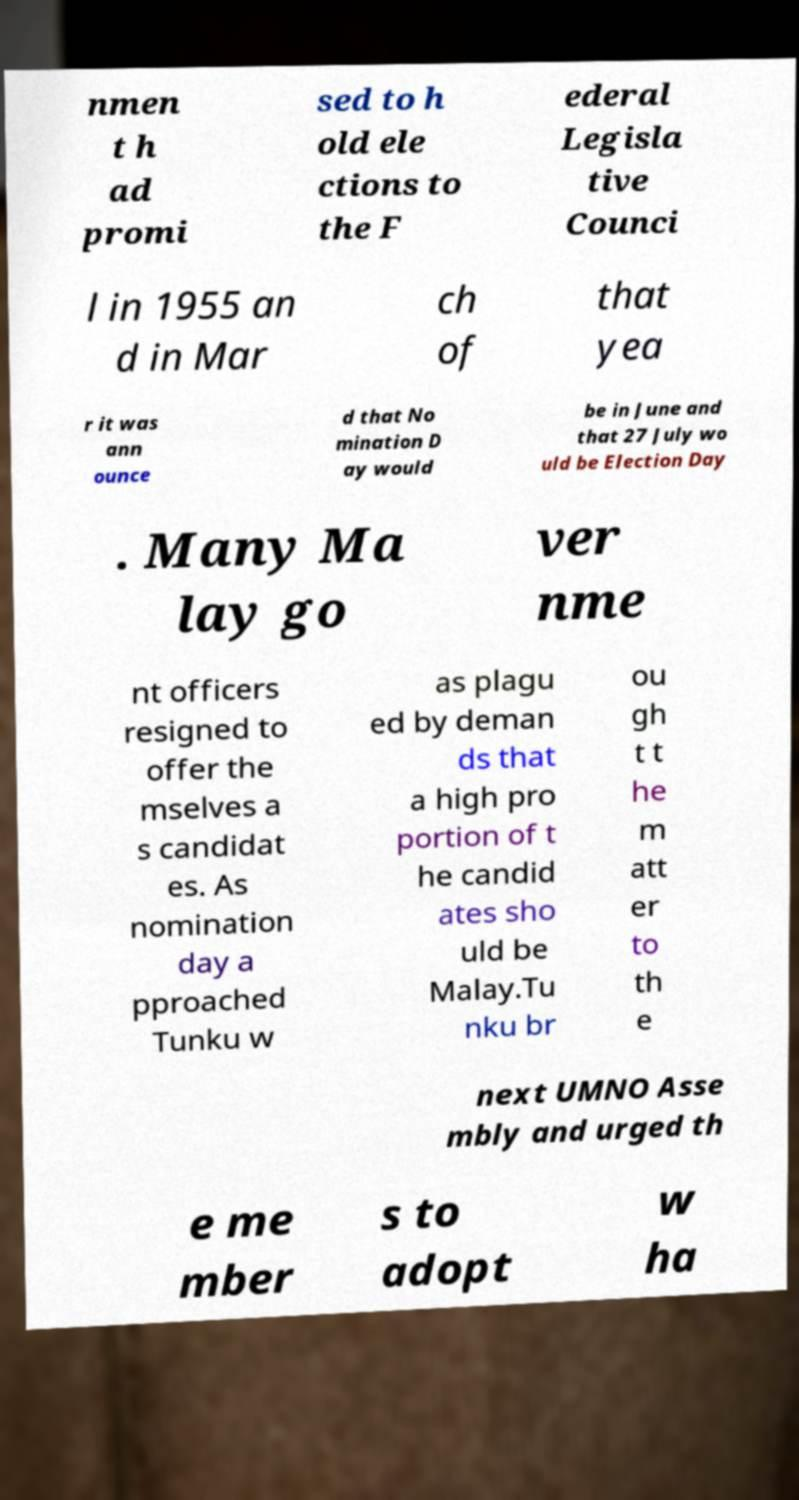Could you assist in decoding the text presented in this image and type it out clearly? nmen t h ad promi sed to h old ele ctions to the F ederal Legisla tive Counci l in 1955 an d in Mar ch of that yea r it was ann ounce d that No mination D ay would be in June and that 27 July wo uld be Election Day . Many Ma lay go ver nme nt officers resigned to offer the mselves a s candidat es. As nomination day a pproached Tunku w as plagu ed by deman ds that a high pro portion of t he candid ates sho uld be Malay.Tu nku br ou gh t t he m att er to th e next UMNO Asse mbly and urged th e me mber s to adopt w ha 